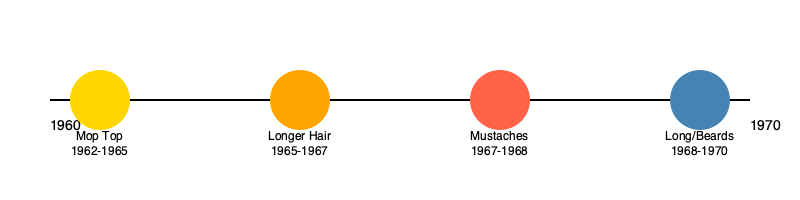Which iconic hairstyle, introduced around 1962 and lasting until about 1965, marked the beginning of Beatlemania and became synonymous with the band's early image? To answer this question, let's examine the evolution of The Beatles' hairstyles throughout their career:

1. 1960-1962: The Beatles started with a more conventional 1950s-style haircut.

2. 1962-1965: The band adopted their iconic "Mop Top" hairstyle. This look featured longer hair brushed forward and down over the forehead, with a straight fringe. It was a radical departure from the typical men's hairstyles of the time and became instantly recognizable.

3. 1965-1967: The Beatles began growing their hair longer, moving away from the neat Mop Top look. This coincided with their more experimental musical phase.

4. 1967-1968: The band members started sporting mustaches, most notably during the Sgt. Pepper era.

5. 1968-1970: In their final years, The Beatles embraced even longer hair and beards, reflecting the hippie movement of the late 1960s.

The hairstyle that marked the beginning of Beatlemania and became synonymous with the band's early image was the Mop Top, introduced around 1962 and lasting until about 1965.
Answer: Mop Top 